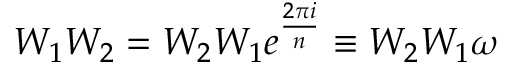Convert formula to latex. <formula><loc_0><loc_0><loc_500><loc_500>W _ { 1 } W _ { 2 } = W _ { 2 } W _ { 1 } e ^ { \frac { 2 \pi i } { n } } \equiv W _ { 2 } W _ { 1 } \omega</formula> 